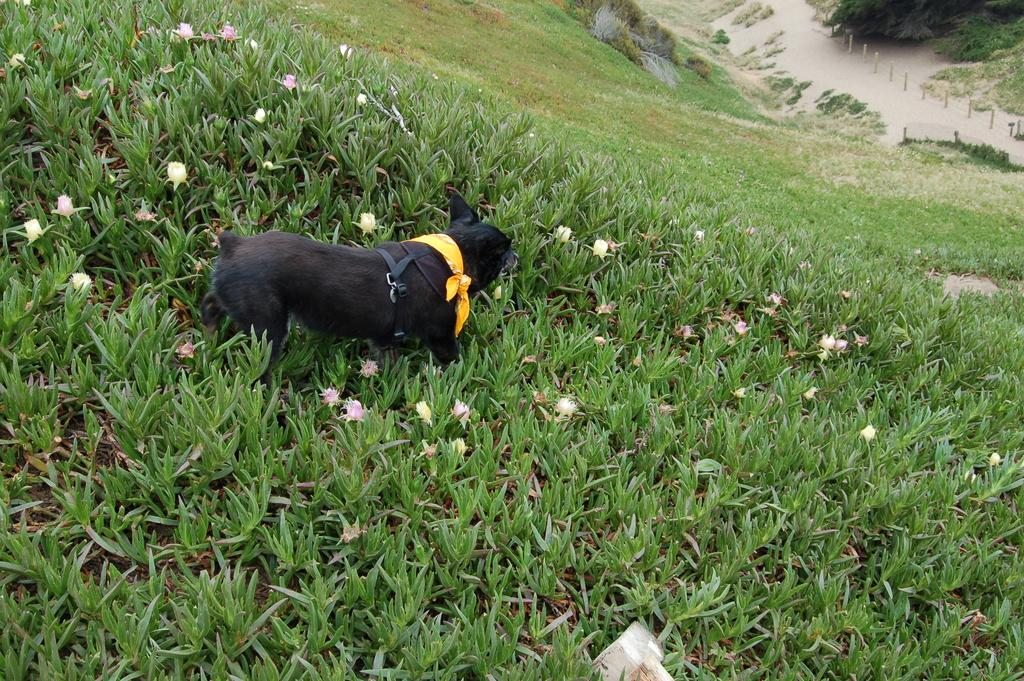What animal is present in the image? There is a dog in the image. Where is the dog located? The dog is on the surface of small plants. What type of plants are present in the image? The plants have flowers. What type of trees can be seen in the background of the image? There are no trees visible in the image; it only features a dog on small plants with flowers. 